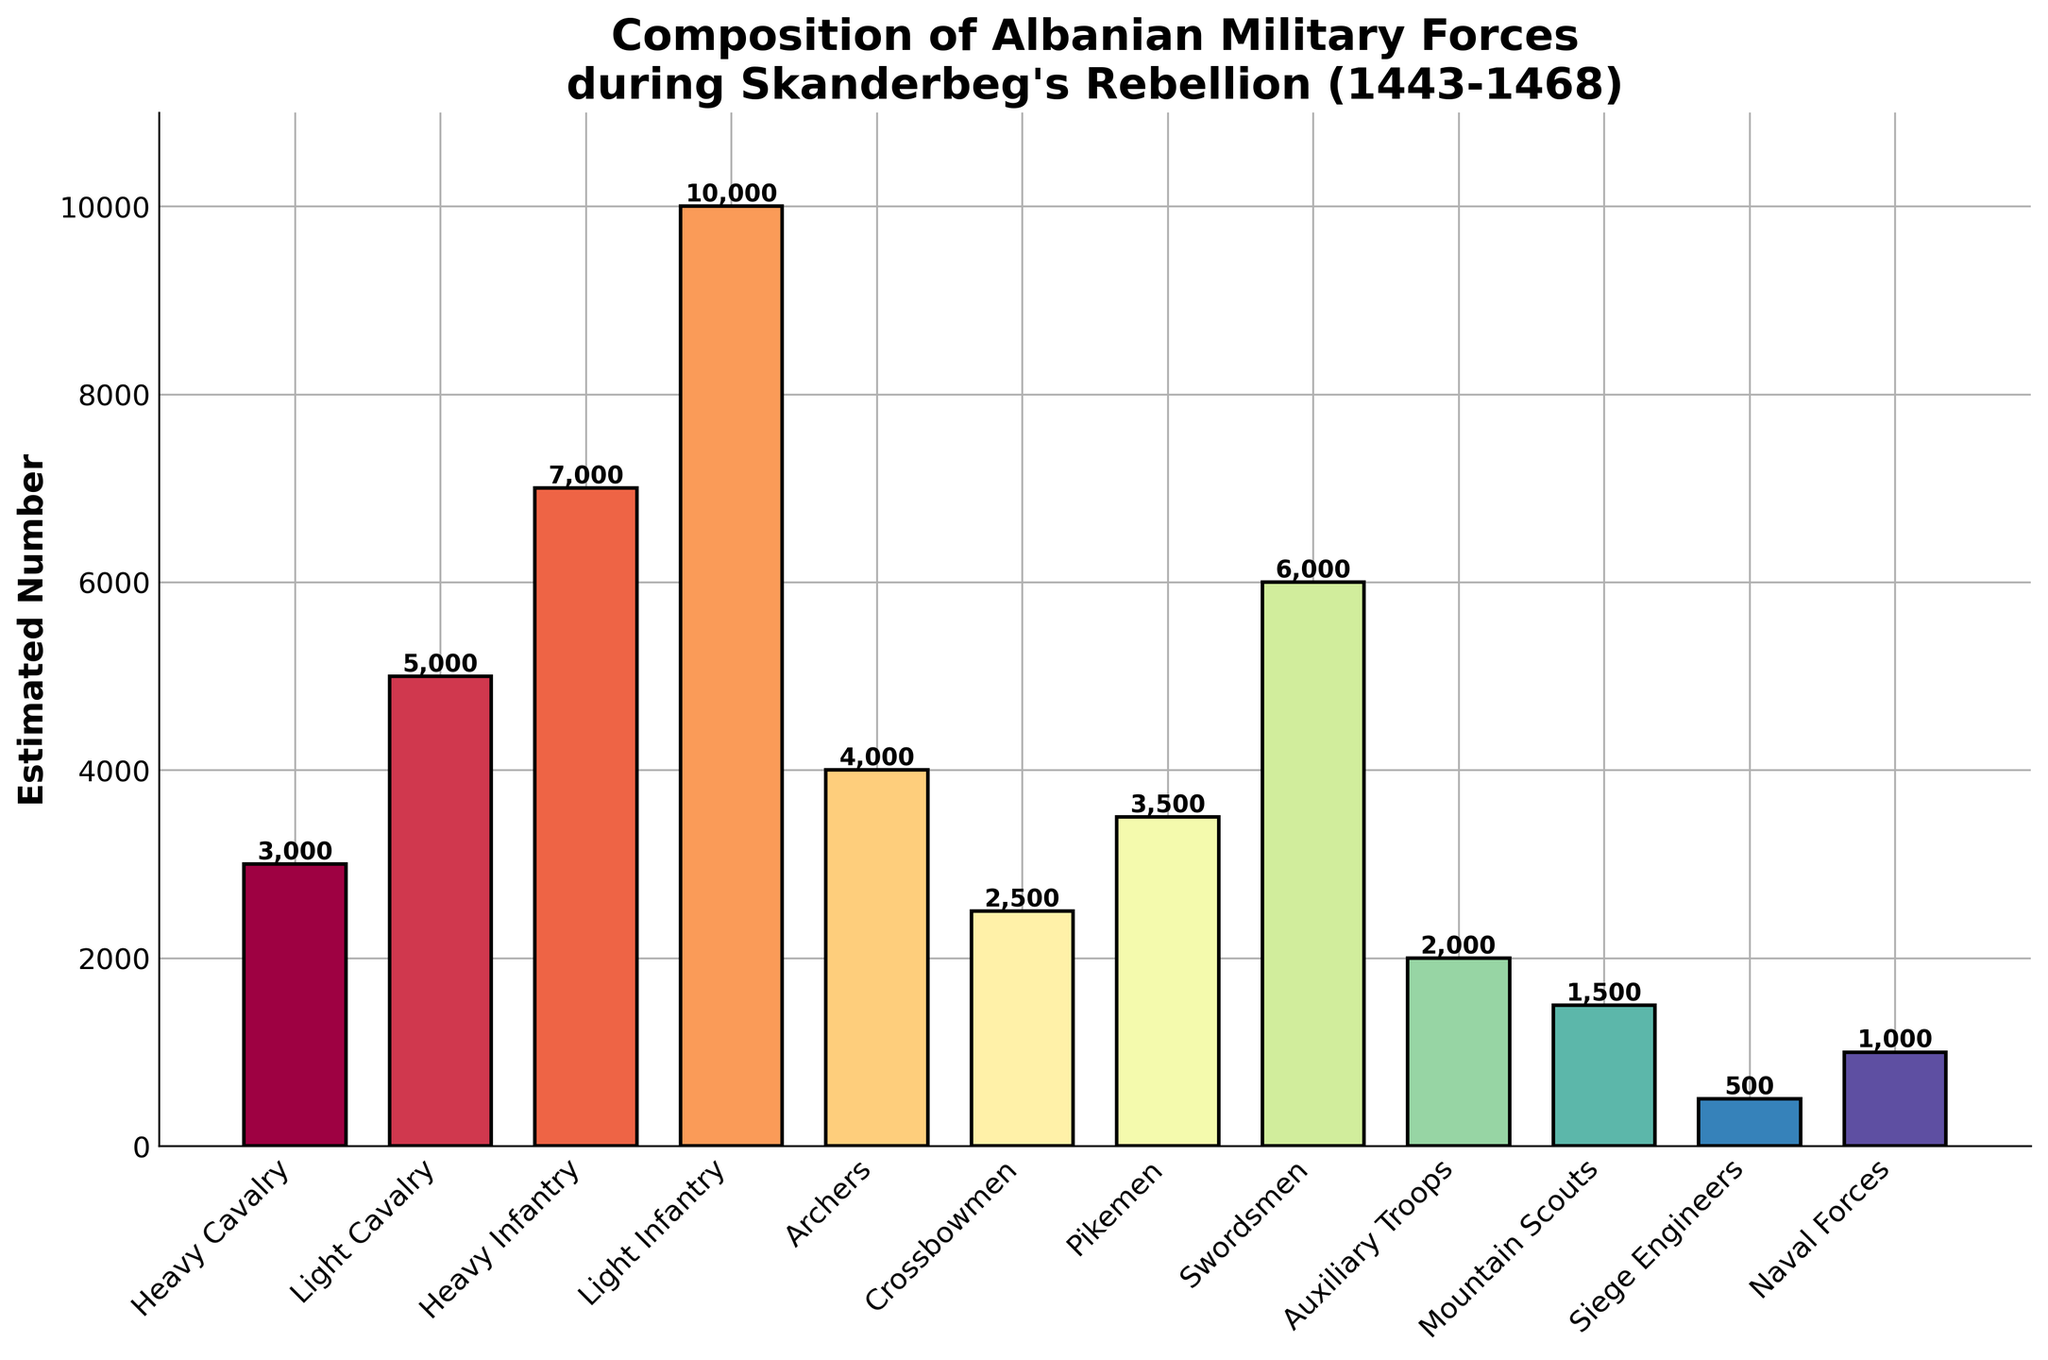Which troop type has the highest estimated number of forces? The bar for Light Infantry is the tallest, indicating it has the highest estimated number.
Answer: Light Infantry How many more Light Infantry are there compared to Swordsmen? The estimated number for Light Infantry is 10,000 and for Swordsmen is 6,000. Subtracting these gives 10,000 - 6,000 = 4,000.
Answer: 4,000 What is the total estimated number of Cavalry troops? Sum the estimated numbers of Heavy Cavalry (3,000) and Light Cavalry (5,000). The total is 3,000 + 5,000 = 8,000.
Answer: 8,000 Which is greater: the number of Archers or Crossbowmen, and by how much? The estimated number for Archers is 4,000, and for Crossbowmen, it is 2,500. Subtracting these gives 4,000 - 2,500 = 1,500.
Answer: Archers by 1,500 What is the estimated number of forces dedicated to siege engineering compared to mountain scouting? The bar for Siege Engineers shows 500, while the bar for Mountain Scouts shows 1,500.
Answer: Siege Engineers have 1,000 fewer forces than Mountain Scouts What is the combined number of Auxiliary Troops, Mountain Scouts, and Naval Forces? Sum the estimated numbers of Auxiliary Troops (2,000), Mountain Scouts (1,500), and Naval Forces (1,000). The total is 2,000 + 1,500 + 1,000 = 4,500.
Answer: 4,500 How does the number of Pikemen compare to that of Heavy Infantry? The Pikemen are 3,500 and Heavy Infantry are 7,000. 3,500 is half of 7,000.
Answer: Pikemen are half of Heavy Infantry What is the average estimated number of Light Cavalry and Light Infantry? Add Light Cavalry (5,000) and Light Infantry (10,000), then divide by 2. (5,000 + 10,000) / 2 = 7,500.
Answer: 7,500 Which troop type has the smallest representation? The shortest bar represents Siege Engineers, with an estimated number of 500.
Answer: Siege Engineers What is the difference in the number of Swordsmen and Naval Forces? Subtract the number of Naval Forces (1,000) from Swordsmen (6,000). 6,000 - 1,000 = 5,000.
Answer: 5,000 